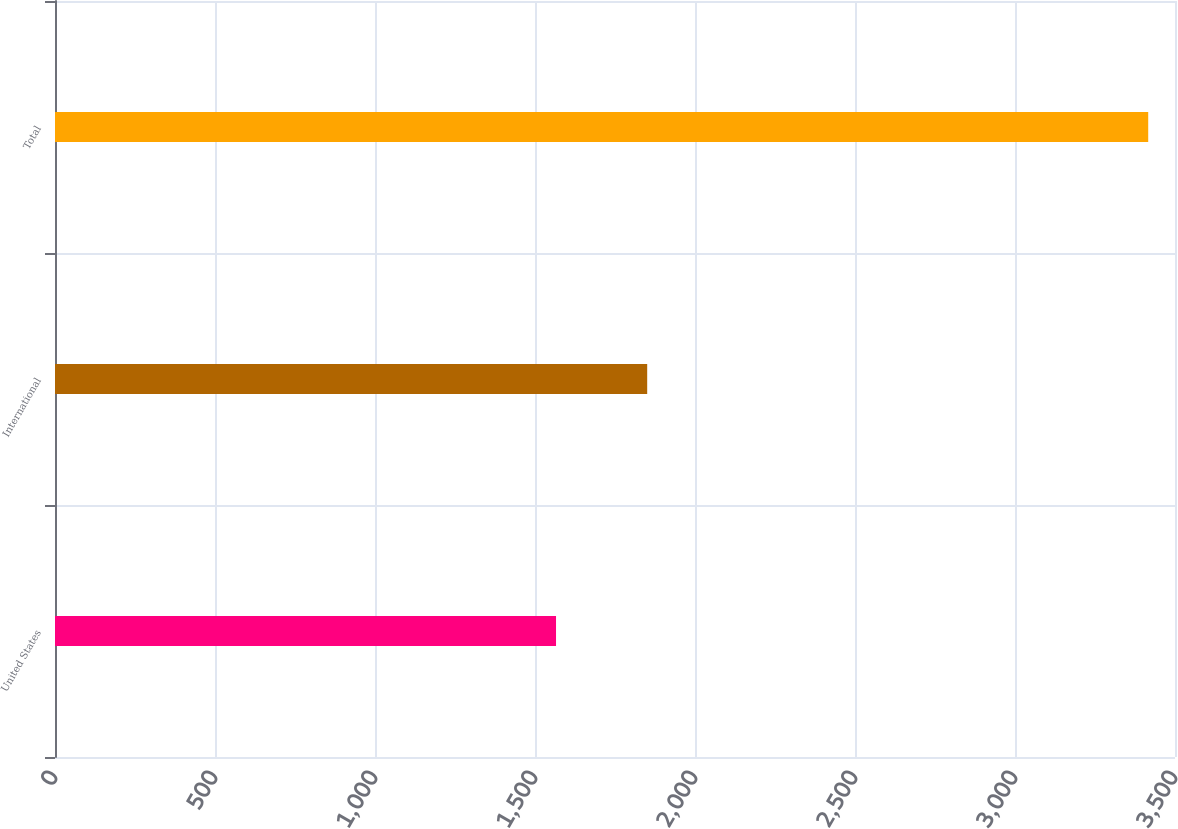<chart> <loc_0><loc_0><loc_500><loc_500><bar_chart><fcel>United States<fcel>International<fcel>Total<nl><fcel>1565.7<fcel>1850.6<fcel>3416.3<nl></chart> 